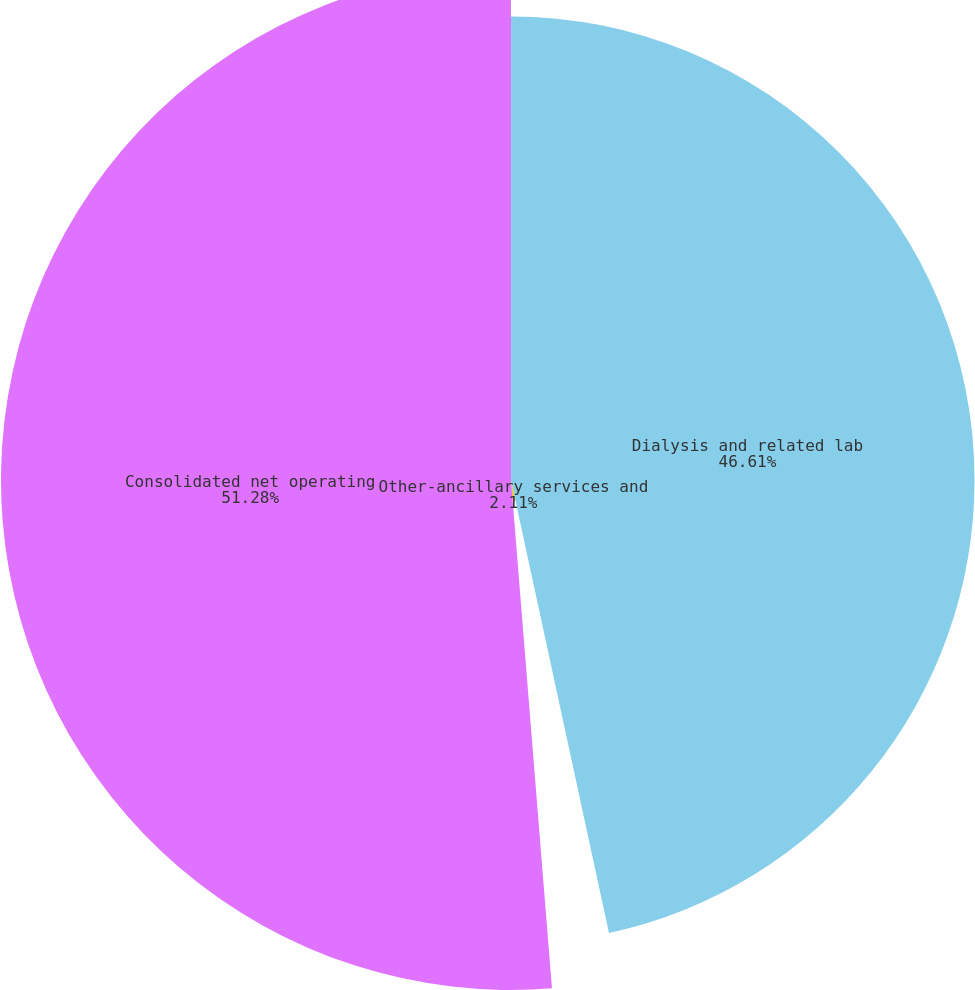Convert chart to OTSL. <chart><loc_0><loc_0><loc_500><loc_500><pie_chart><fcel>Dialysis and related lab<fcel>Other-ancillary services and<fcel>Consolidated net operating<nl><fcel>46.61%<fcel>2.11%<fcel>51.28%<nl></chart> 